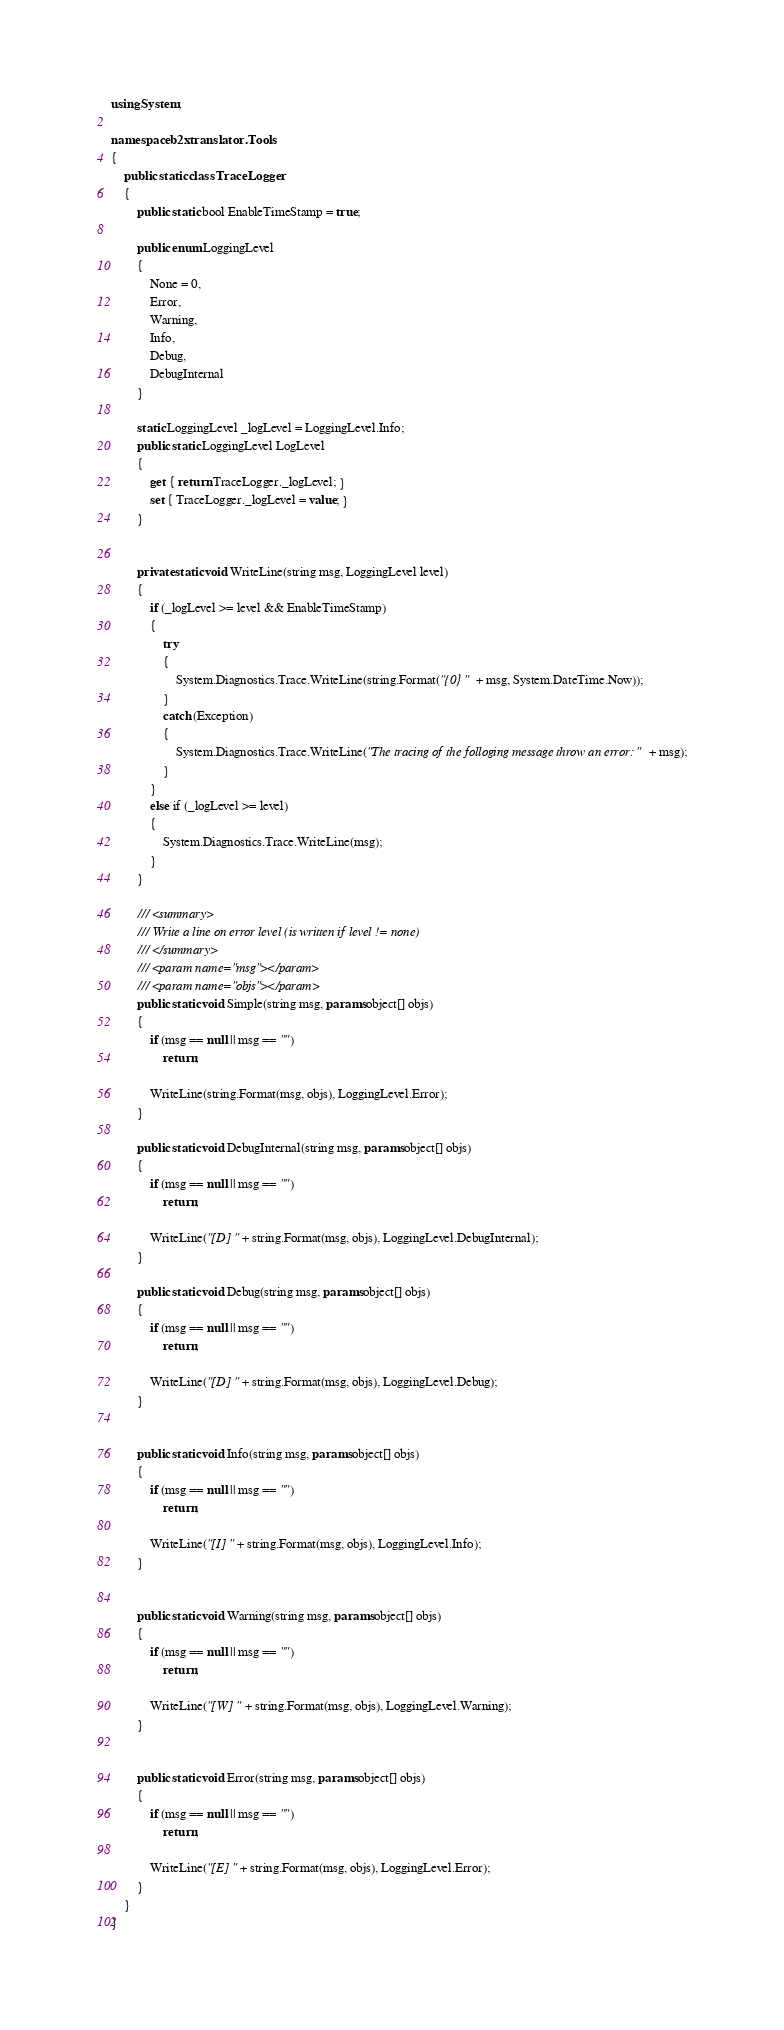<code> <loc_0><loc_0><loc_500><loc_500><_C#_>using System;

namespace b2xtranslator.Tools
{
    public static class TraceLogger
    {
        public static bool EnableTimeStamp = true;

        public enum LoggingLevel
        {
            None = 0,
            Error,
            Warning,
            Info,
            Debug,
            DebugInternal
        }

        static LoggingLevel _logLevel = LoggingLevel.Info;
        public static LoggingLevel LogLevel
        {
            get { return TraceLogger._logLevel; }
            set { TraceLogger._logLevel = value; }
        }


        private static void WriteLine(string msg, LoggingLevel level)
        {
            if (_logLevel >= level && EnableTimeStamp)
            {
                try
                {
                    System.Diagnostics.Trace.WriteLine(string.Format("{0} " + msg, System.DateTime.Now));
                }
                catch (Exception)
                {
                    System.Diagnostics.Trace.WriteLine("The tracing of the folloging message throw an error: " + msg);
                }
            }
            else if (_logLevel >= level)
            {
                System.Diagnostics.Trace.WriteLine(msg);
            }
        }

        /// <summary>
        /// Write a line on error level (is written if level != none)
        /// </summary>
        /// <param name="msg"></param>
        /// <param name="objs"></param>
        public static void Simple(string msg, params object[] objs)
        {
            if (msg == null || msg == "")
                return;

            WriteLine(string.Format(msg, objs), LoggingLevel.Error);
        }

        public static void DebugInternal(string msg, params object[] objs)
        {
            if (msg == null || msg == "")
                return;

            WriteLine("[D] " + string.Format(msg, objs), LoggingLevel.DebugInternal);
        }

        public static void Debug(string msg, params object[] objs)
        {
            if (msg == null || msg == "")
                return;

            WriteLine("[D] " + string.Format(msg, objs), LoggingLevel.Debug);
        }


        public static void Info(string msg, params object[] objs)
        {
            if (msg == null || msg == "")
                return;

            WriteLine("[I] " + string.Format(msg, objs), LoggingLevel.Info);
        }


        public static void Warning(string msg, params object[] objs)
        {
            if (msg == null || msg == "")
                return;

            WriteLine("[W] " + string.Format(msg, objs), LoggingLevel.Warning);
        }


        public static void Error(string msg, params object[] objs)
        {
            if (msg == null || msg == "")
                return;

            WriteLine("[E] " + string.Format(msg, objs), LoggingLevel.Error);
        }
    }
}

</code> 